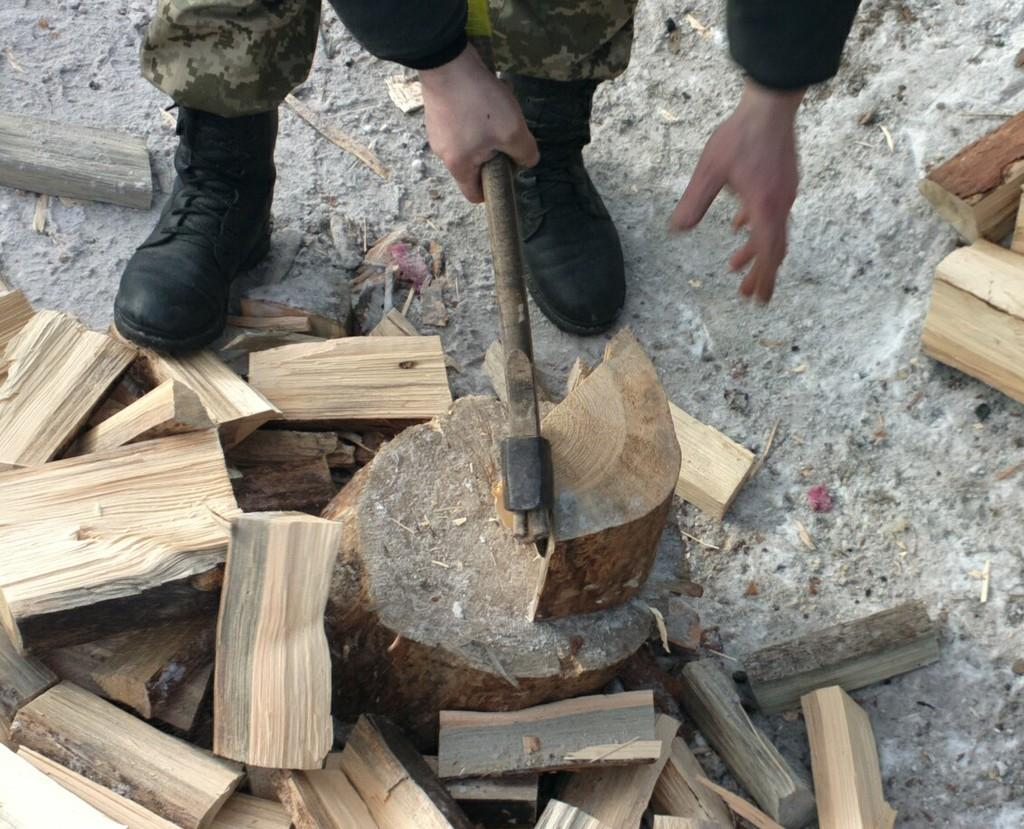What body parts of a person can be seen in the image? Human legs and hands are visible in the image. What is the person holding in the image? The person is holding an axe in the image. What can be found on the ground in the image? There are wooden pieces on the ground in the image. What type of texture can be seen on the bridge in the image? There is no bridge present in the image; it features a person holding an axe and wooden pieces on the ground. 